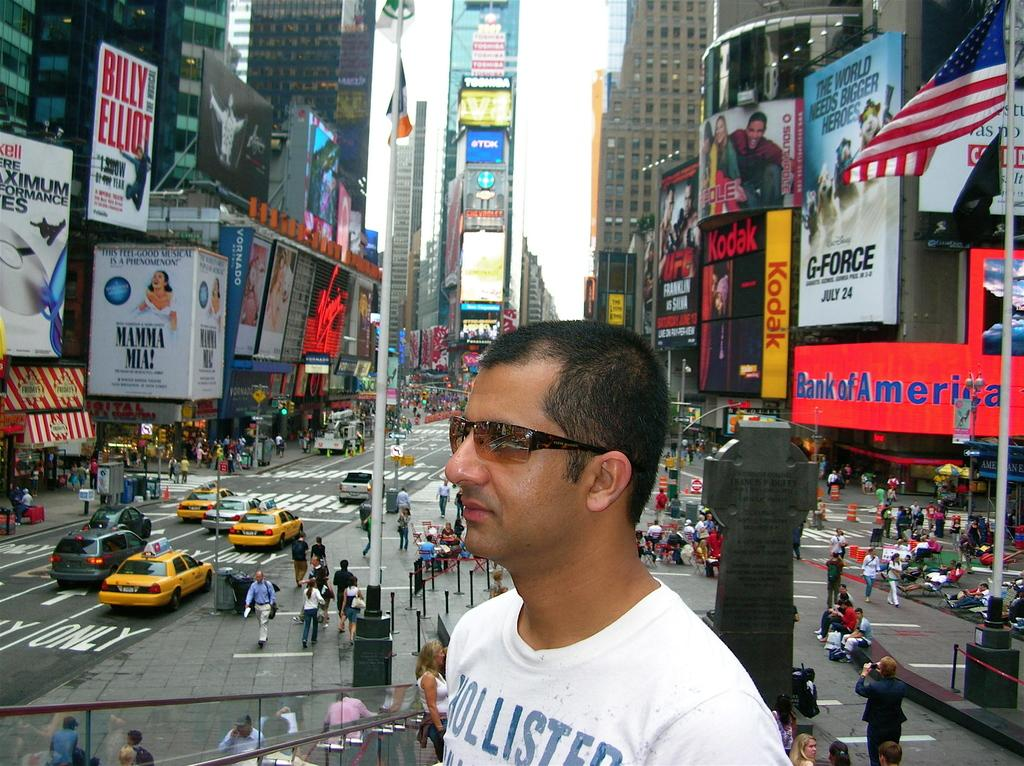Provide a one-sentence caption for the provided image. a shirt that has the word Hollister on it. 